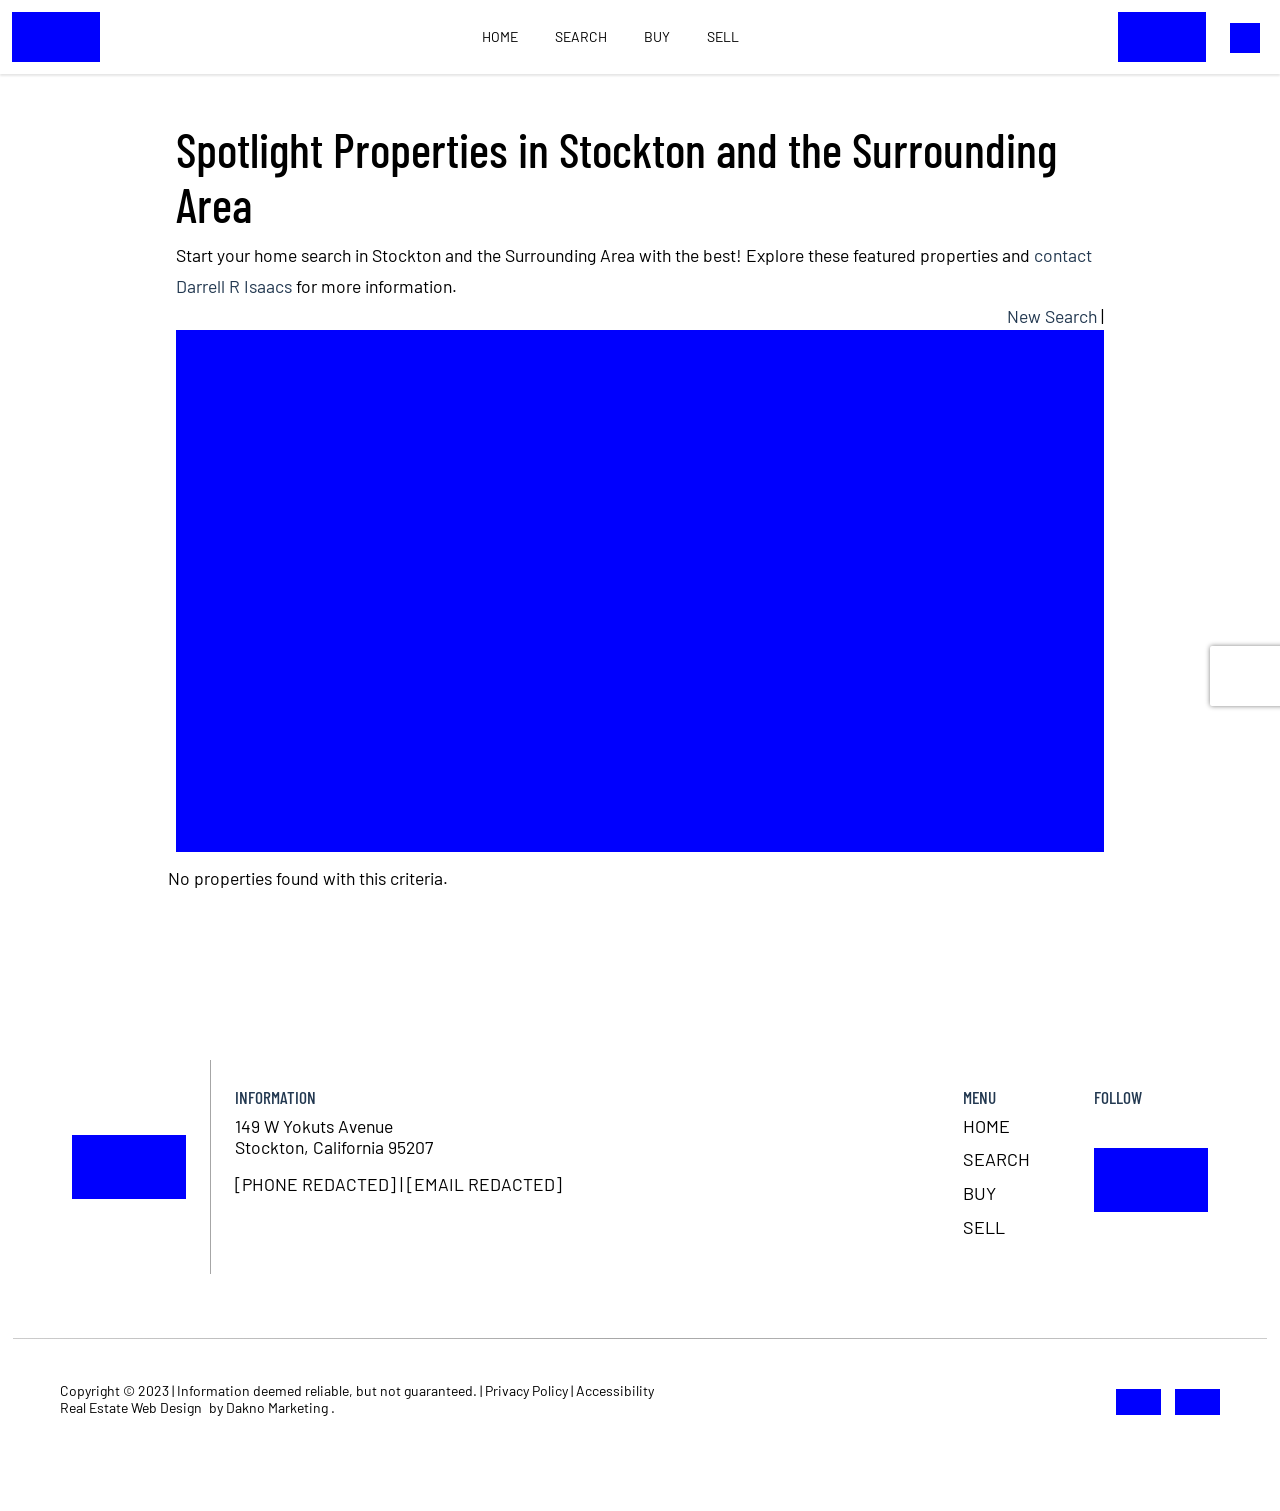What are the design elements that make this website user-friendly for real estate browsing? The design elements that enhance user-friendliness for real estate browsing on this website include a clean and clutter-free layout that focuses on property visuals, an easy-to-navigate menu with clear categories such as Home, Search, Buy, and Sell. Furthermore, the website likely incorporates responsive design to ensure it works well across all devices, and search filters that allow users to sort properties by different criteria like price, area, or number of bedrooms. Providing a search bar prominently at the top helps users quickly find specific properties. 